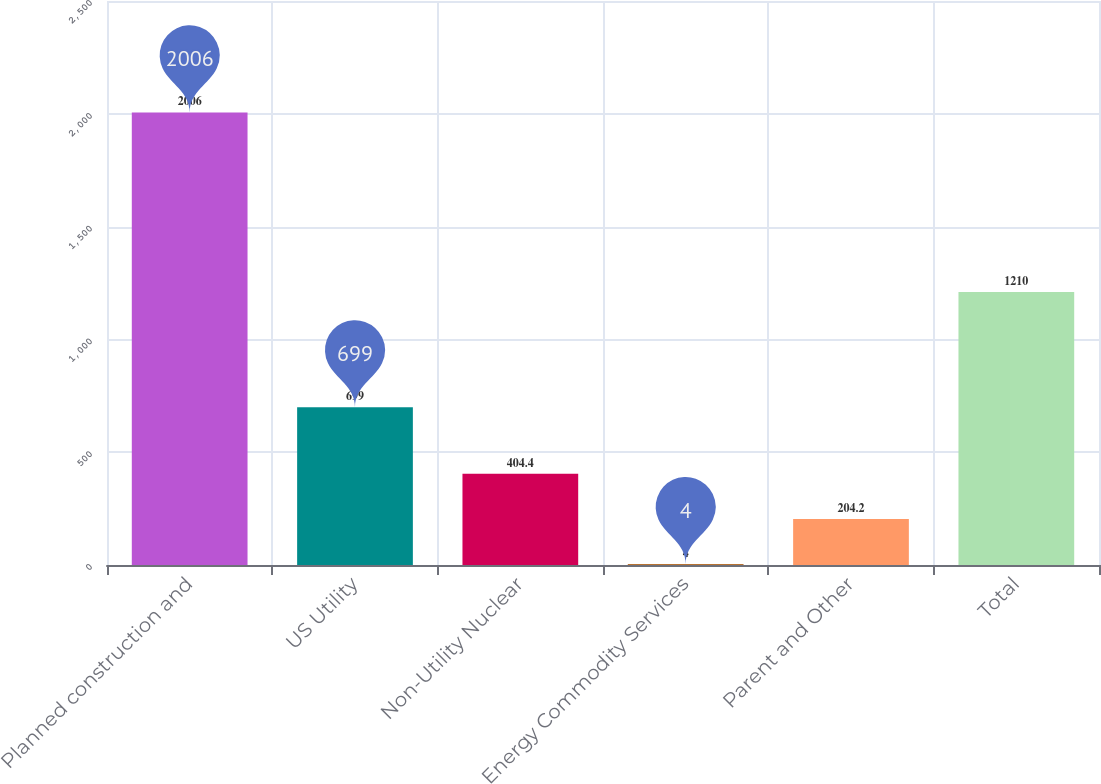<chart> <loc_0><loc_0><loc_500><loc_500><bar_chart><fcel>Planned construction and<fcel>US Utility<fcel>Non-Utility Nuclear<fcel>Energy Commodity Services<fcel>Parent and Other<fcel>Total<nl><fcel>2006<fcel>699<fcel>404.4<fcel>4<fcel>204.2<fcel>1210<nl></chart> 